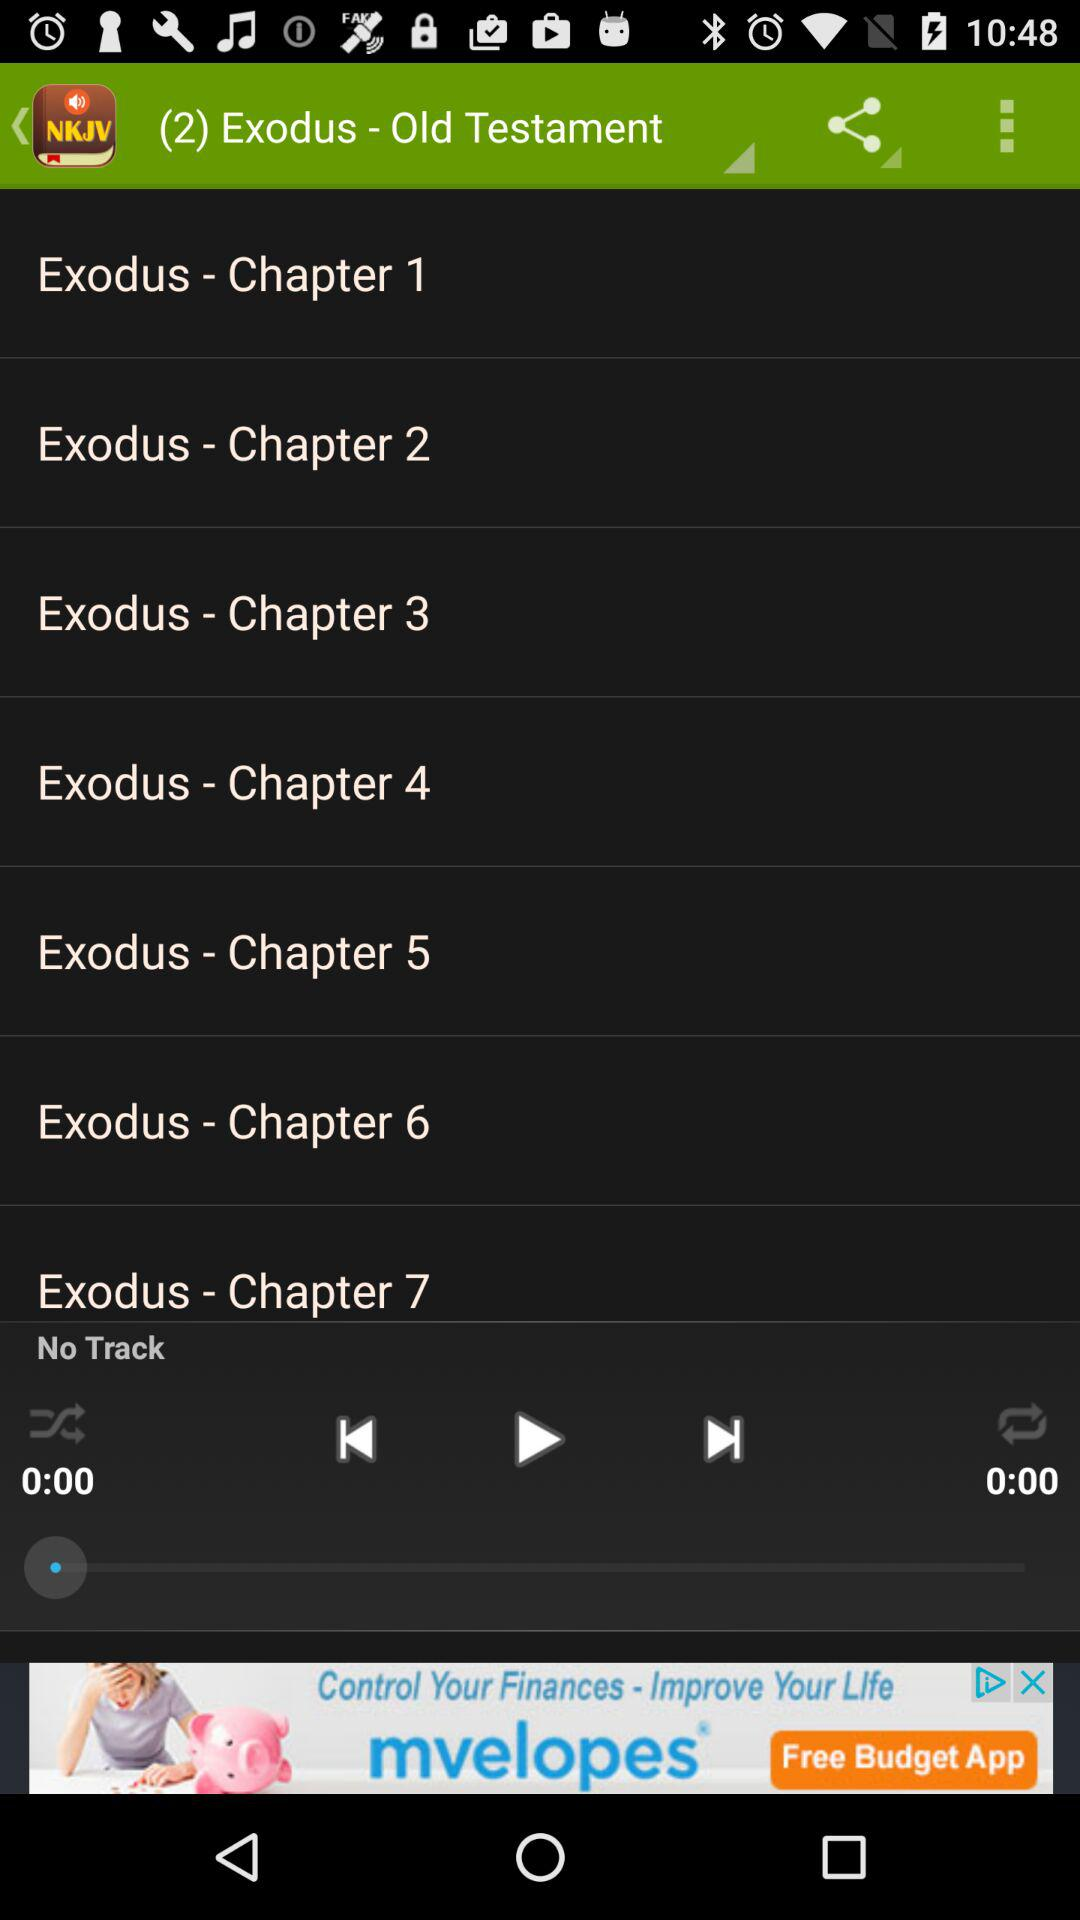How many chapters are available in total?
Answer the question using a single word or phrase. 7 